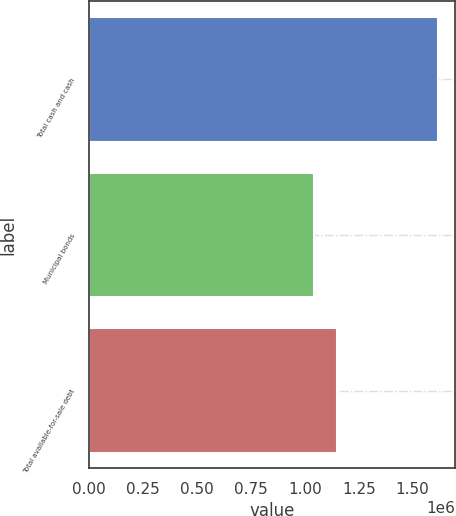Convert chart. <chart><loc_0><loc_0><loc_500><loc_500><bar_chart><fcel>Total cash and cash<fcel>Municipal bonds<fcel>Total available-for-sale debt<nl><fcel>1.61801e+06<fcel>1.04362e+06<fcel>1.14847e+06<nl></chart> 